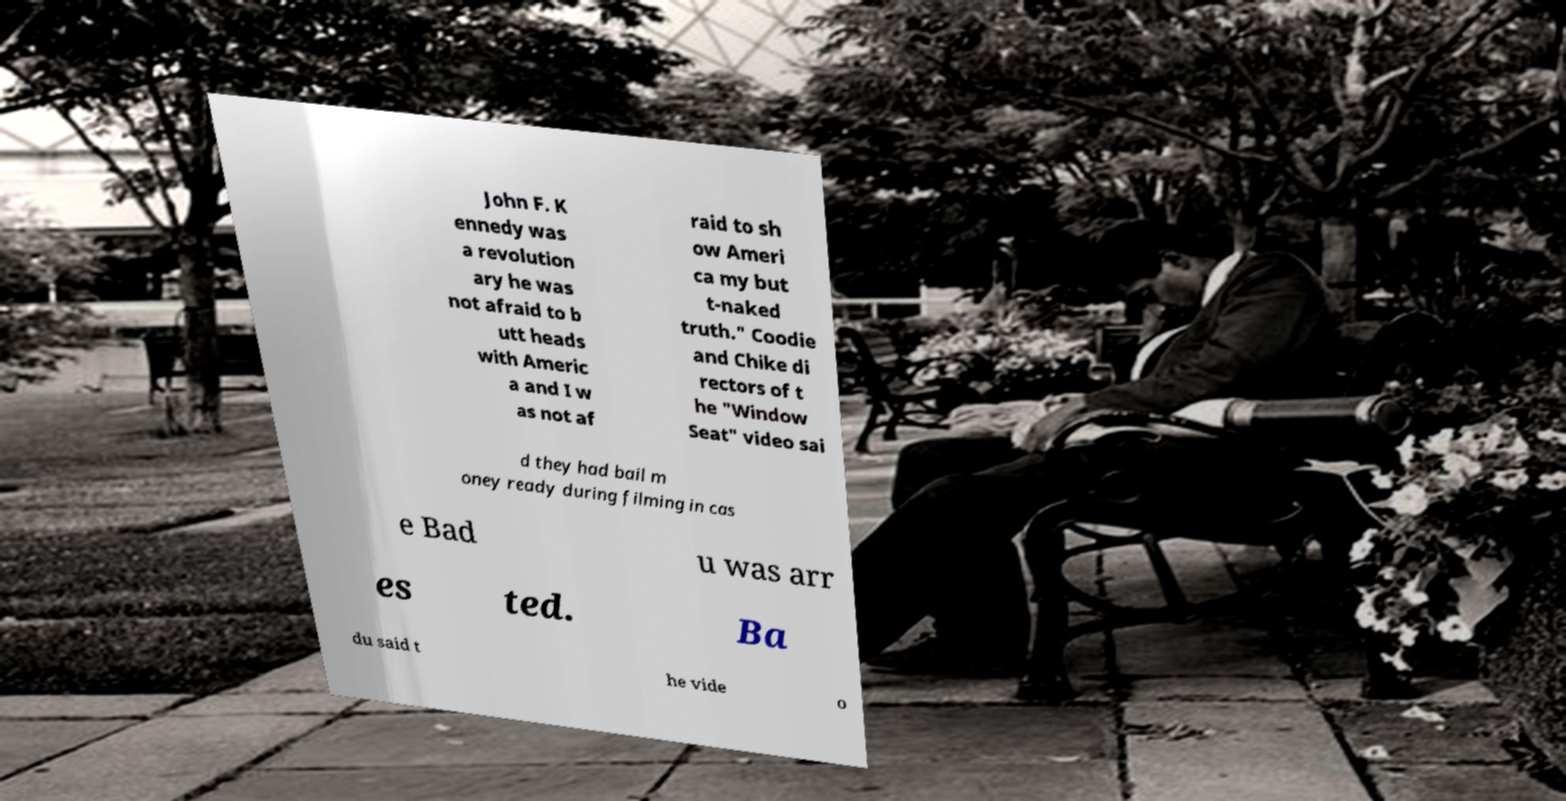I need the written content from this picture converted into text. Can you do that? John F. K ennedy was a revolution ary he was not afraid to b utt heads with Americ a and I w as not af raid to sh ow Ameri ca my but t-naked truth." Coodie and Chike di rectors of t he "Window Seat" video sai d they had bail m oney ready during filming in cas e Bad u was arr es ted. Ba du said t he vide o 